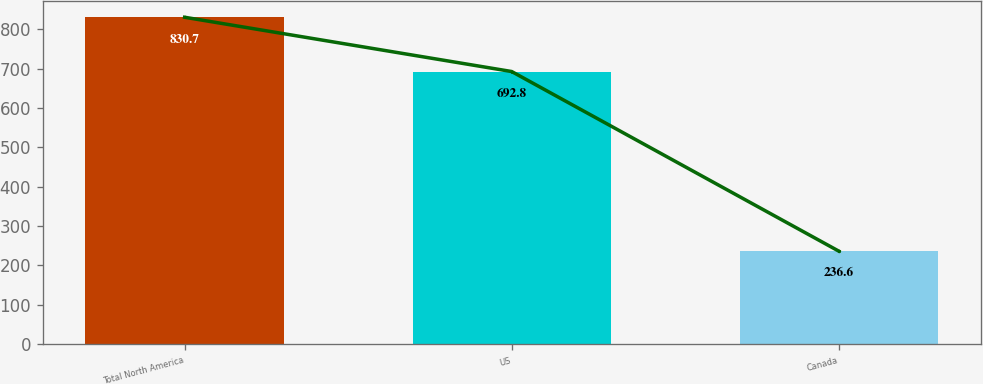Convert chart. <chart><loc_0><loc_0><loc_500><loc_500><bar_chart><fcel>Total North America<fcel>US<fcel>Canada<nl><fcel>830.7<fcel>692.8<fcel>236.6<nl></chart> 